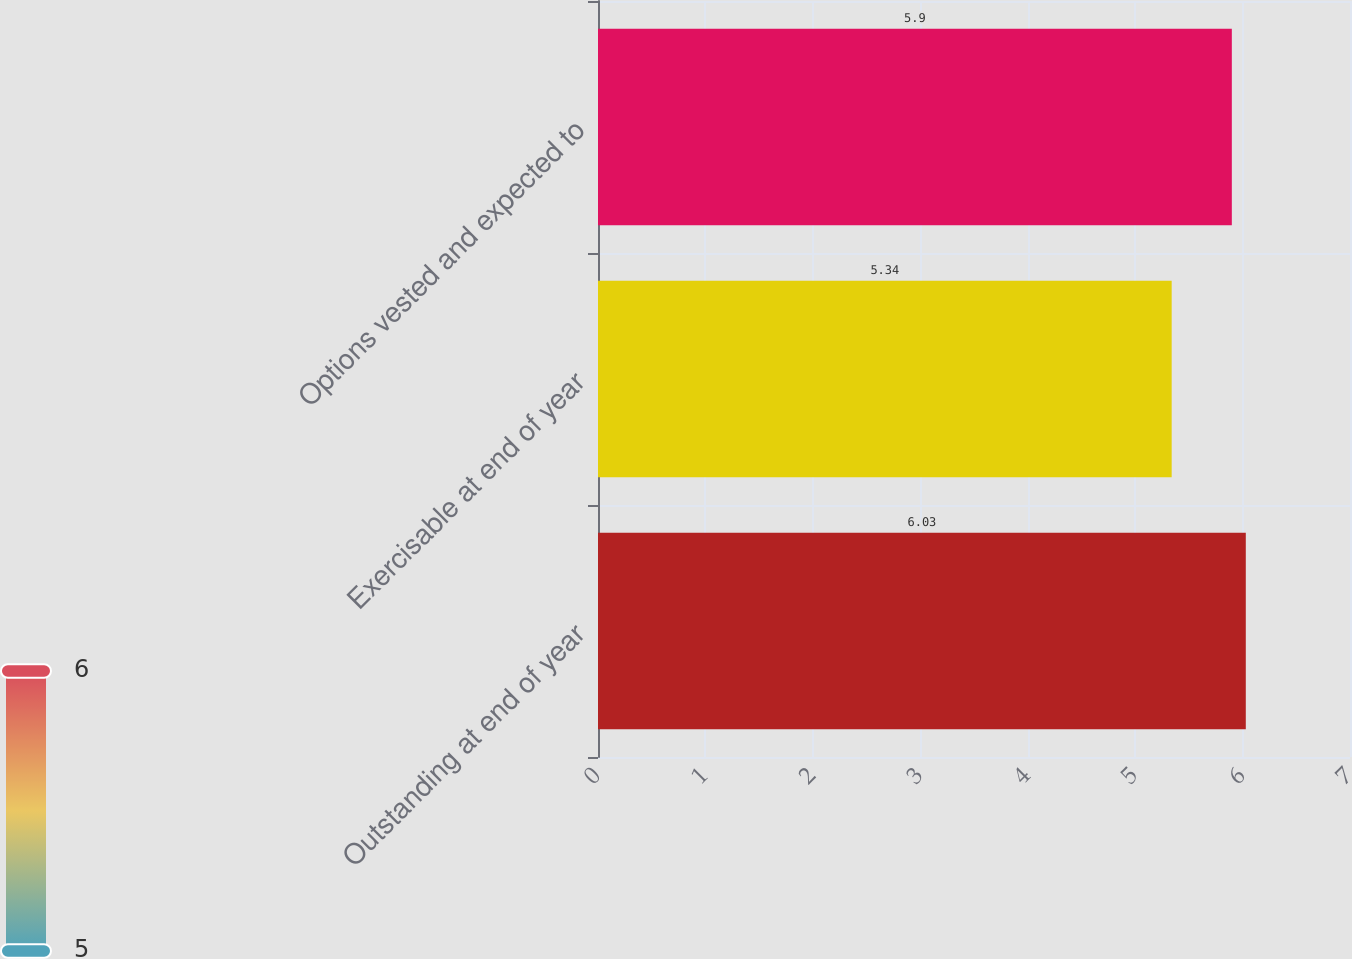Convert chart to OTSL. <chart><loc_0><loc_0><loc_500><loc_500><bar_chart><fcel>Outstanding at end of year<fcel>Exercisable at end of year<fcel>Options vested and expected to<nl><fcel>6.03<fcel>5.34<fcel>5.9<nl></chart> 